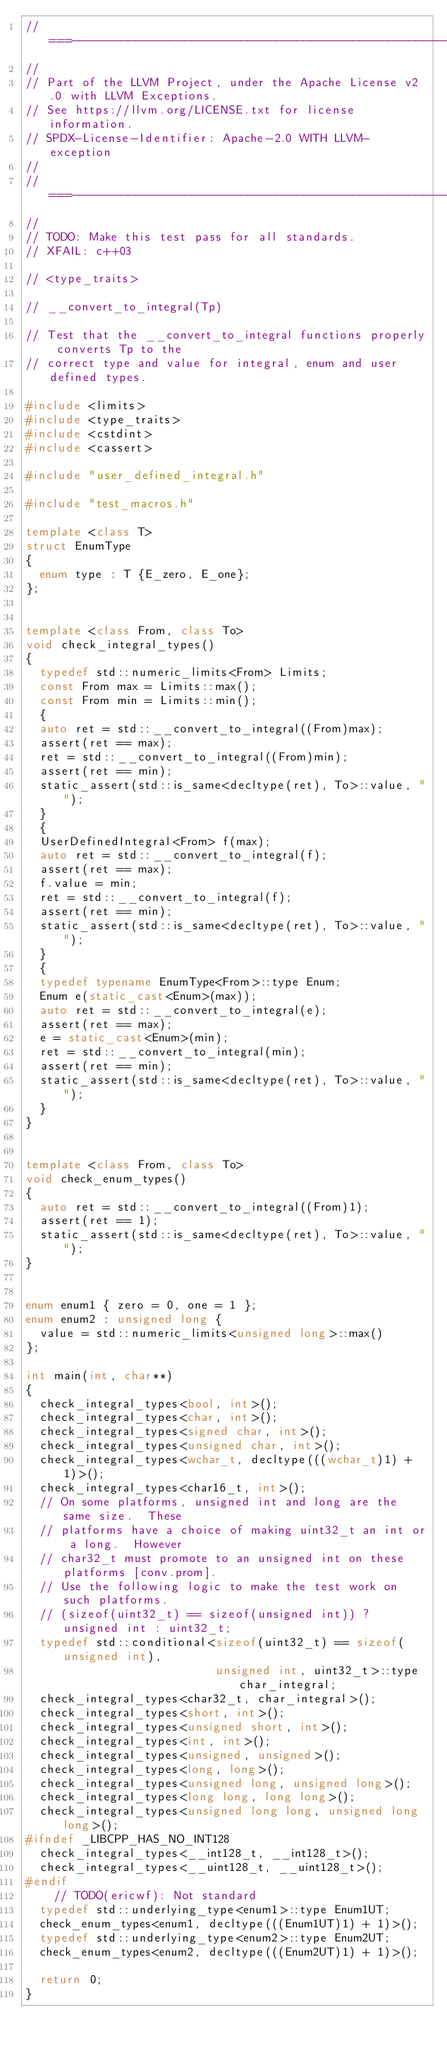<code> <loc_0><loc_0><loc_500><loc_500><_C++_>//===----------------------------------------------------------------------===//
//
// Part of the LLVM Project, under the Apache License v2.0 with LLVM Exceptions.
// See https://llvm.org/LICENSE.txt for license information.
// SPDX-License-Identifier: Apache-2.0 WITH LLVM-exception
//
//===----------------------------------------------------------------------===//
//
// TODO: Make this test pass for all standards.
// XFAIL: c++03

// <type_traits>

// __convert_to_integral(Tp)

// Test that the __convert_to_integral functions properly converts Tp to the
// correct type and value for integral, enum and user defined types.

#include <limits>
#include <type_traits>
#include <cstdint>
#include <cassert>

#include "user_defined_integral.h"

#include "test_macros.h"

template <class T>
struct EnumType
{
  enum type : T {E_zero, E_one};
};


template <class From, class To>
void check_integral_types()
{
  typedef std::numeric_limits<From> Limits;
  const From max = Limits::max();
  const From min = Limits::min();
  {
  auto ret = std::__convert_to_integral((From)max);
  assert(ret == max);
  ret = std::__convert_to_integral((From)min);
  assert(ret == min);
  static_assert(std::is_same<decltype(ret), To>::value, "");
  }
  {
  UserDefinedIntegral<From> f(max);
  auto ret = std::__convert_to_integral(f);
  assert(ret == max);
  f.value = min;
  ret = std::__convert_to_integral(f);
  assert(ret == min);
  static_assert(std::is_same<decltype(ret), To>::value, "");
  }
  {
  typedef typename EnumType<From>::type Enum;
  Enum e(static_cast<Enum>(max));
  auto ret = std::__convert_to_integral(e);
  assert(ret == max);
  e = static_cast<Enum>(min);
  ret = std::__convert_to_integral(min);
  assert(ret == min);
  static_assert(std::is_same<decltype(ret), To>::value, "");
  }
}


template <class From, class To>
void check_enum_types()
{
  auto ret = std::__convert_to_integral((From)1);
  assert(ret == 1);
  static_assert(std::is_same<decltype(ret), To>::value, "");
}


enum enum1 { zero = 0, one = 1 };
enum enum2 : unsigned long {
  value = std::numeric_limits<unsigned long>::max()
};

int main(int, char**)
{
  check_integral_types<bool, int>();
  check_integral_types<char, int>();
  check_integral_types<signed char, int>();
  check_integral_types<unsigned char, int>();
  check_integral_types<wchar_t, decltype(((wchar_t)1) + 1)>();
  check_integral_types<char16_t, int>();
  // On some platforms, unsigned int and long are the same size.  These
  // platforms have a choice of making uint32_t an int or a long.  However
  // char32_t must promote to an unsigned int on these platforms [conv.prom].
  // Use the following logic to make the test work on such platforms.
  // (sizeof(uint32_t) == sizeof(unsigned int)) ? unsigned int : uint32_t;
  typedef std::conditional<sizeof(uint32_t) == sizeof(unsigned int),
                           unsigned int, uint32_t>::type char_integral;
  check_integral_types<char32_t, char_integral>();
  check_integral_types<short, int>();
  check_integral_types<unsigned short, int>();
  check_integral_types<int, int>();
  check_integral_types<unsigned, unsigned>();
  check_integral_types<long, long>();
  check_integral_types<unsigned long, unsigned long>();
  check_integral_types<long long, long long>();
  check_integral_types<unsigned long long, unsigned long long>();
#ifndef _LIBCPP_HAS_NO_INT128
  check_integral_types<__int128_t, __int128_t>();
  check_integral_types<__uint128_t, __uint128_t>();
#endif
    // TODO(ericwf): Not standard
  typedef std::underlying_type<enum1>::type Enum1UT;
  check_enum_types<enum1, decltype(((Enum1UT)1) + 1)>();
  typedef std::underlying_type<enum2>::type Enum2UT;
  check_enum_types<enum2, decltype(((Enum2UT)1) + 1)>();

  return 0;
}
</code> 